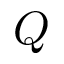Convert formula to latex. <formula><loc_0><loc_0><loc_500><loc_500>Q</formula> 